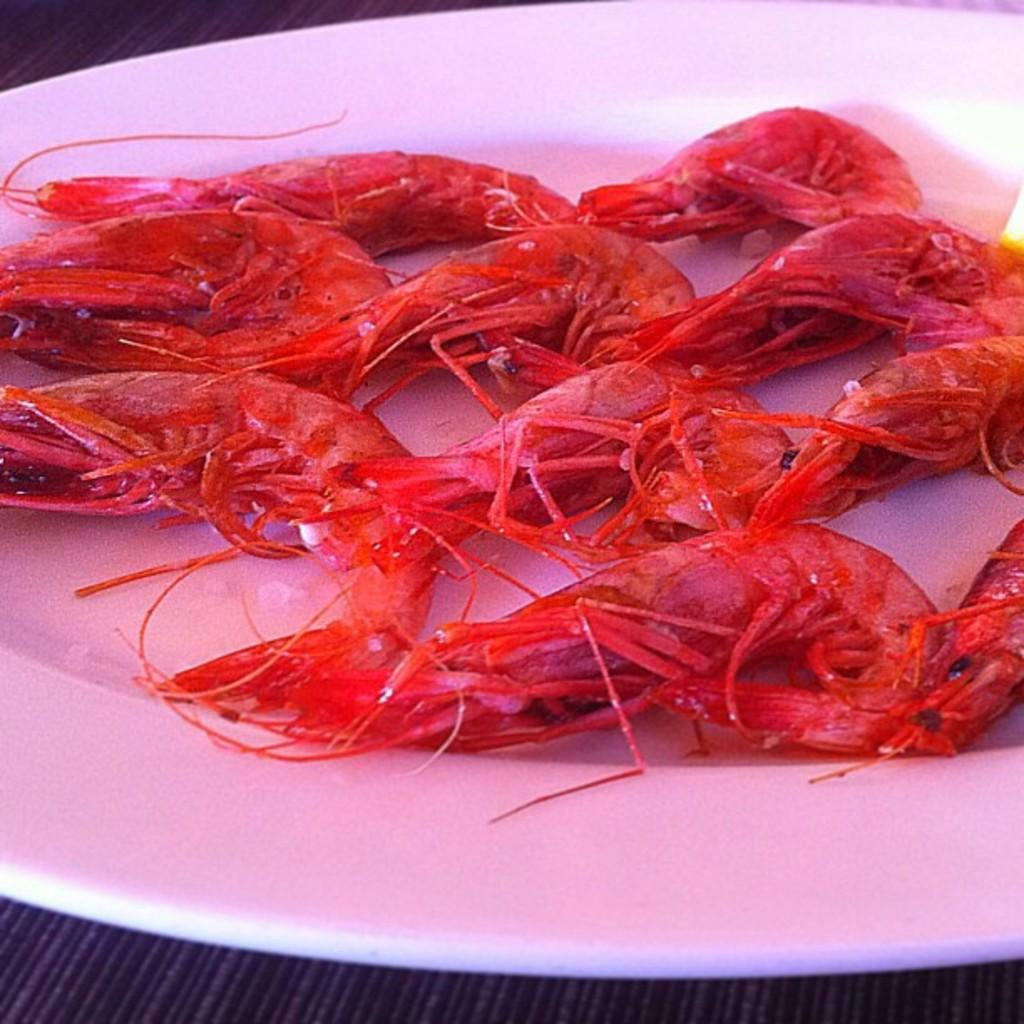What type of food is visible in the image? There is seafood in the image. What color is the plate that the seafood is on? The plate is on a white color plate. Where is the plate located in the image? The plate is on a surface. Reasoning: Let'g: Let's think step by step in order to produce the conversation. We start by identifying the main subject in the image, which is the seafood. Then, we expand the conversation to include details about the plate, such as its color and location. Each question is designed to elicit a specific detail about the image that is known from the provided facts. Absurd Question/Answer: What type of toothpaste is visible on the plate in the image? There is no toothpaste present in the image; it features seafood on a white color plate. What type of lumber is used to make the plate in the image? The plate is not made of lumber; it is a dishware item, likely ceramic or porcelain. What type of leaf is visible on the plate in the image? There is no leaf present on the plate in the image; it features seafood on a white color plate. 